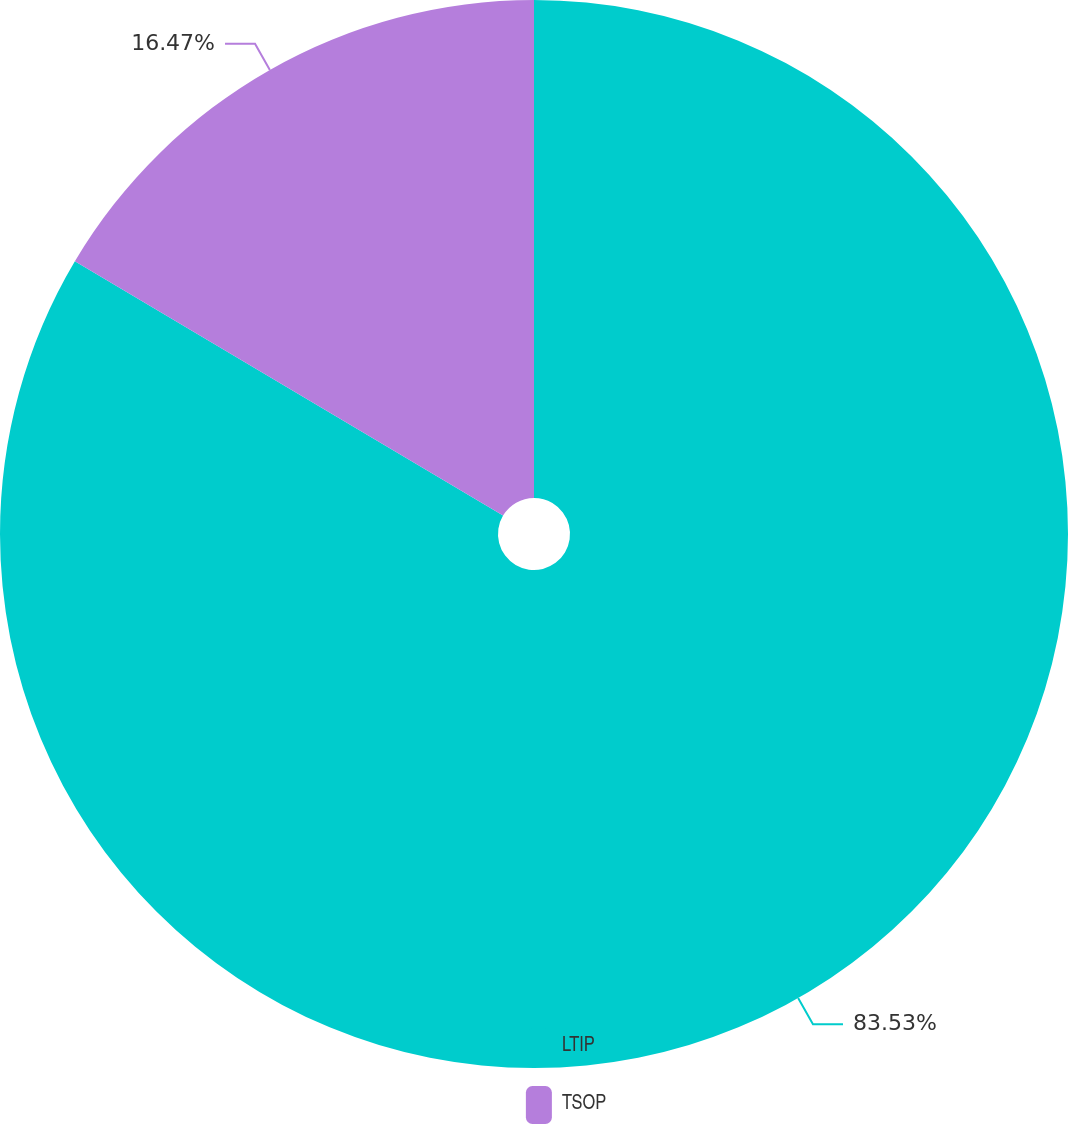Convert chart. <chart><loc_0><loc_0><loc_500><loc_500><pie_chart><fcel>LTIP<fcel>TSOP<nl><fcel>83.53%<fcel>16.47%<nl></chart> 